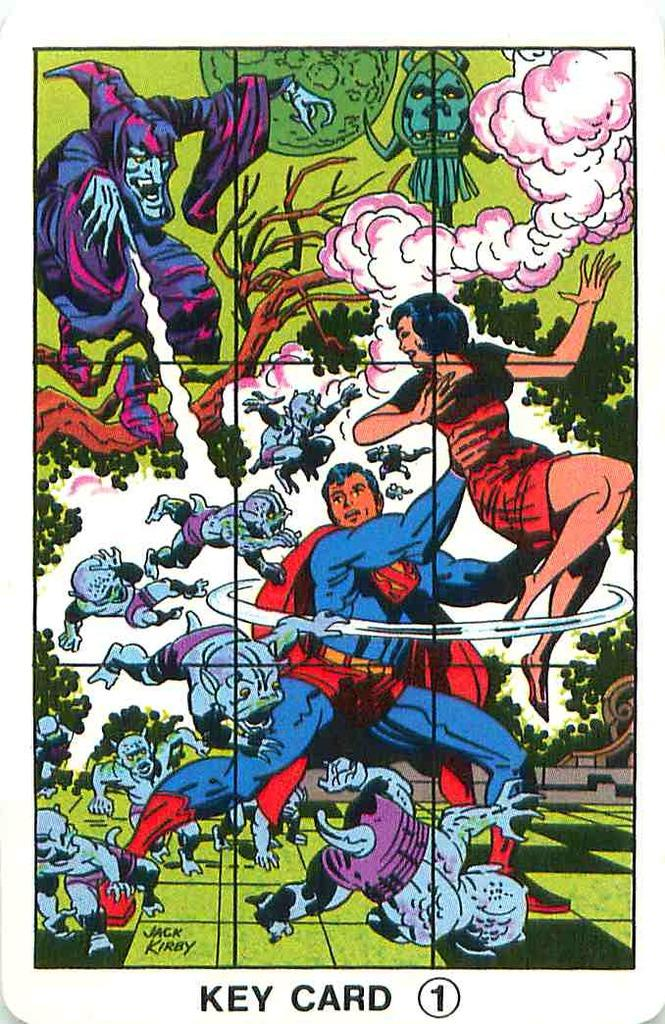What is the main subject of the image? The main subject of the image is a painting. What else can be seen on the painting? There is text written on the painting. How many owls can be seen in the painting? There are no owls present in the painting; it only features a painting with text written on it. What route does the painting depict in the image? The painting does not depict a route; it is a painting with text written on it. 